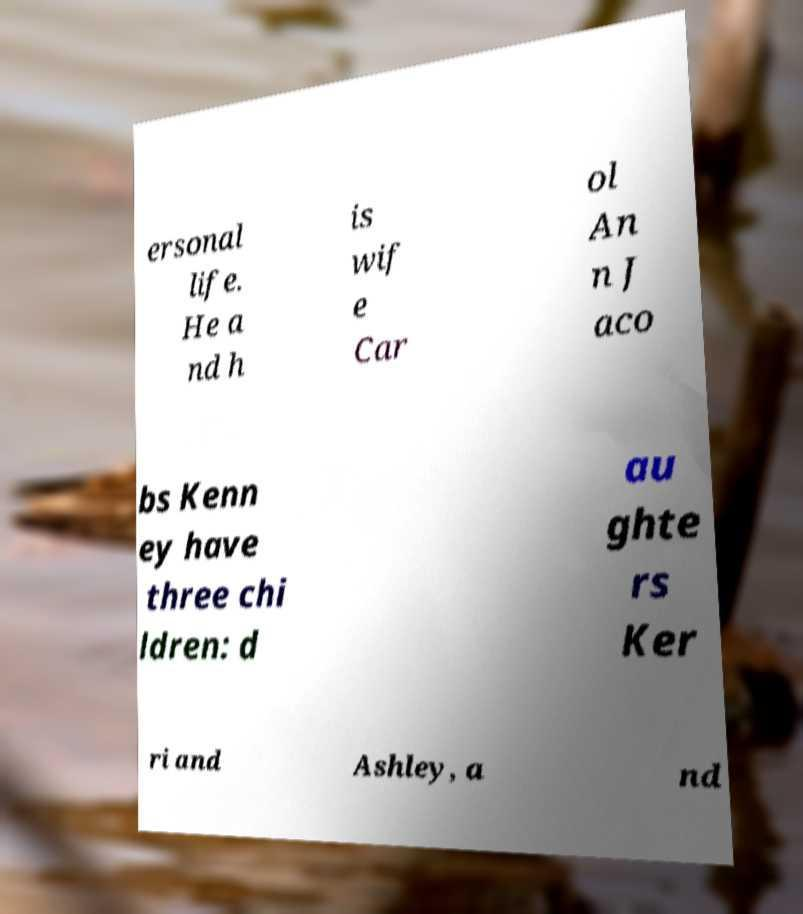Please identify and transcribe the text found in this image. ersonal life. He a nd h is wif e Car ol An n J aco bs Kenn ey have three chi ldren: d au ghte rs Ker ri and Ashley, a nd 